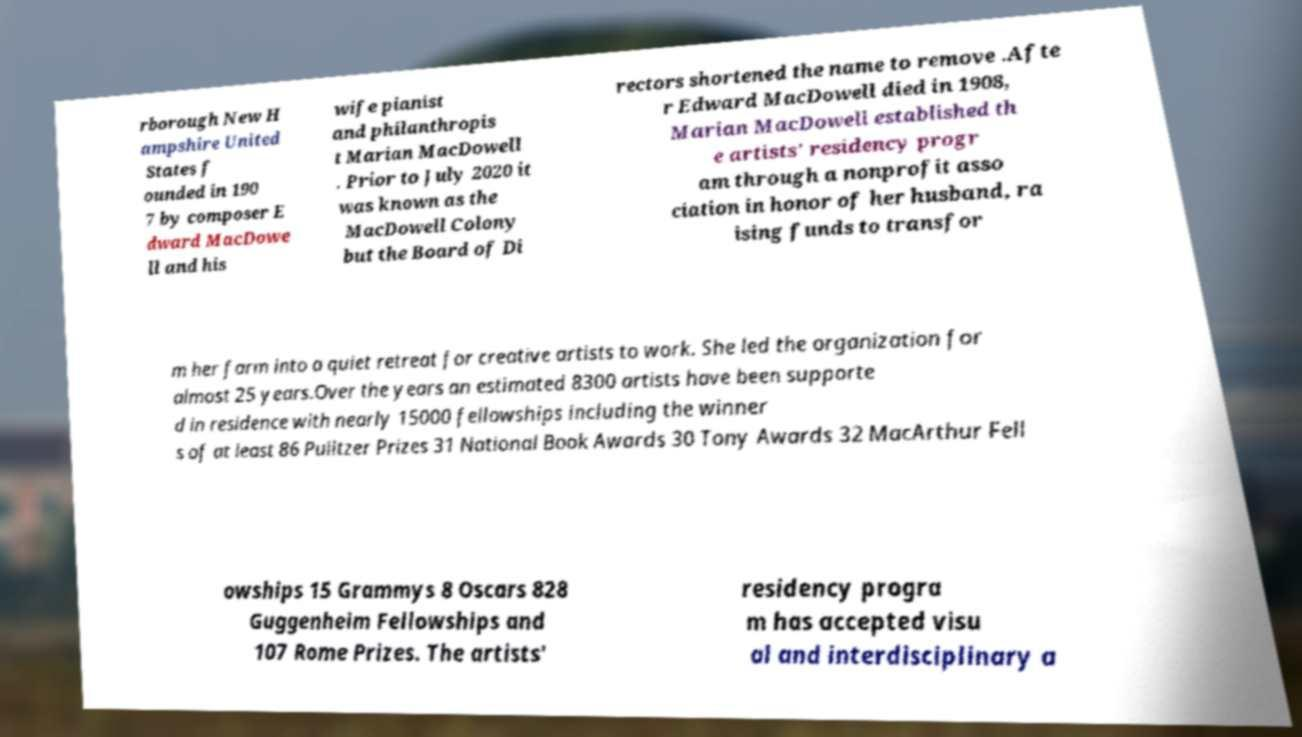There's text embedded in this image that I need extracted. Can you transcribe it verbatim? rborough New H ampshire United States f ounded in 190 7 by composer E dward MacDowe ll and his wife pianist and philanthropis t Marian MacDowell . Prior to July 2020 it was known as the MacDowell Colony but the Board of Di rectors shortened the name to remove .Afte r Edward MacDowell died in 1908, Marian MacDowell established th e artists' residency progr am through a nonprofit asso ciation in honor of her husband, ra ising funds to transfor m her farm into a quiet retreat for creative artists to work. She led the organization for almost 25 years.Over the years an estimated 8300 artists have been supporte d in residence with nearly 15000 fellowships including the winner s of at least 86 Pulitzer Prizes 31 National Book Awards 30 Tony Awards 32 MacArthur Fell owships 15 Grammys 8 Oscars 828 Guggenheim Fellowships and 107 Rome Prizes. The artists' residency progra m has accepted visu al and interdisciplinary a 